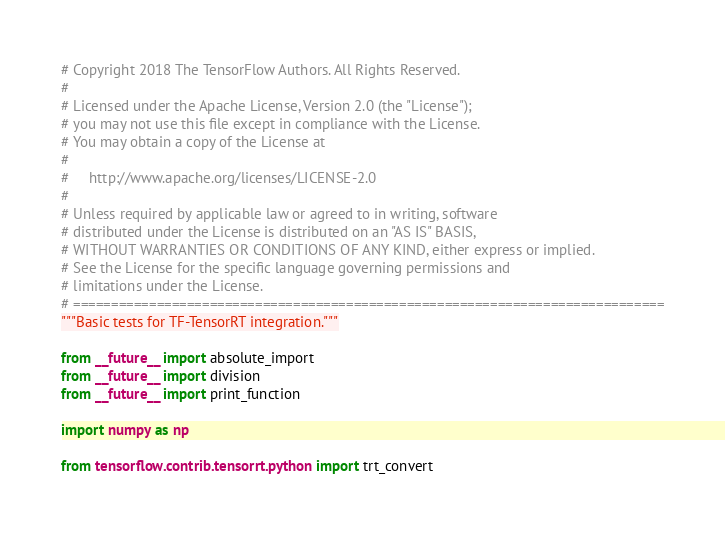<code> <loc_0><loc_0><loc_500><loc_500><_Python_># Copyright 2018 The TensorFlow Authors. All Rights Reserved.
#
# Licensed under the Apache License, Version 2.0 (the "License");
# you may not use this file except in compliance with the License.
# You may obtain a copy of the License at
#
#     http://www.apache.org/licenses/LICENSE-2.0
#
# Unless required by applicable law or agreed to in writing, software
# distributed under the License is distributed on an "AS IS" BASIS,
# WITHOUT WARRANTIES OR CONDITIONS OF ANY KIND, either express or implied.
# See the License for the specific language governing permissions and
# limitations under the License.
# ==============================================================================
"""Basic tests for TF-TensorRT integration."""

from __future__ import absolute_import
from __future__ import division
from __future__ import print_function

import numpy as np

from tensorflow.contrib.tensorrt.python import trt_convert</code> 